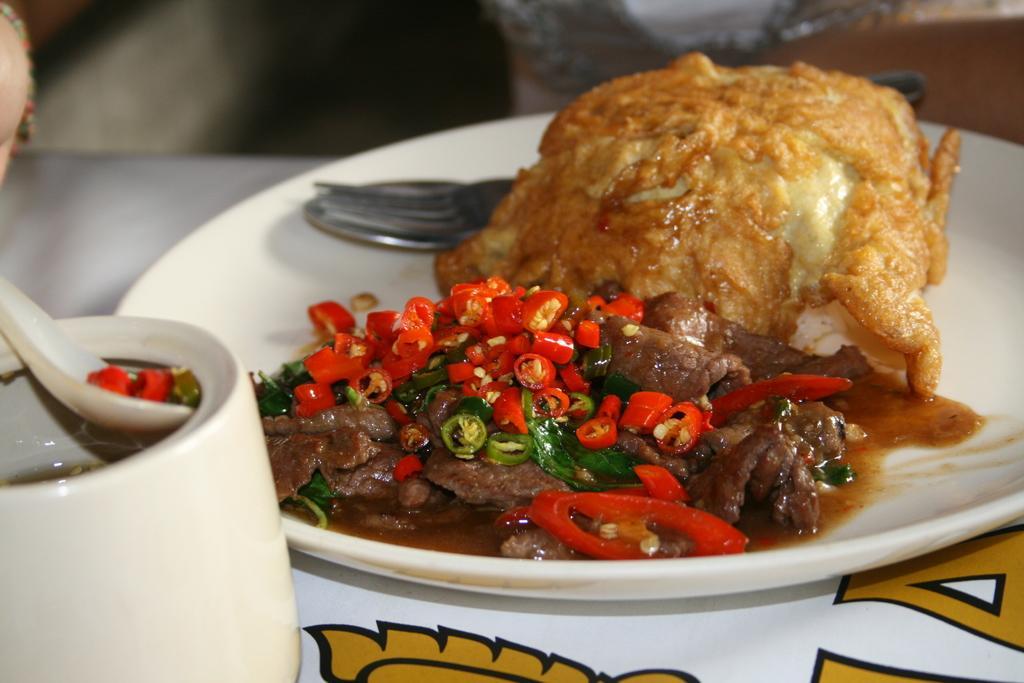Please provide a concise description of this image. On the table we can see a white plate, fork, spoon, red chili, green chili, meat, sauce and other food item. On the bottom left corner there is a pot. On the top left corner we can see a person's hand. Here we can see a chair. 